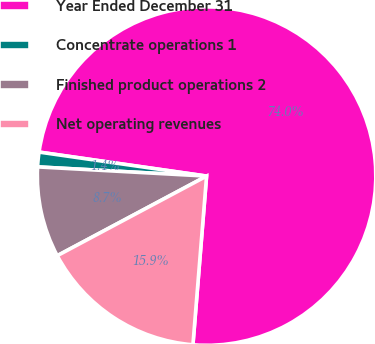Convert chart. <chart><loc_0><loc_0><loc_500><loc_500><pie_chart><fcel>Year Ended December 31<fcel>Concentrate operations 1<fcel>Finished product operations 2<fcel>Net operating revenues<nl><fcel>74.02%<fcel>1.4%<fcel>8.66%<fcel>15.92%<nl></chart> 